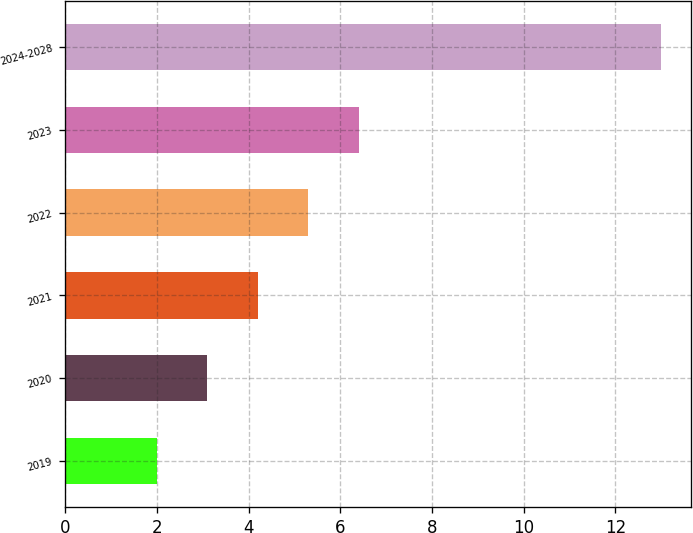Convert chart to OTSL. <chart><loc_0><loc_0><loc_500><loc_500><bar_chart><fcel>2019<fcel>2020<fcel>2021<fcel>2022<fcel>2023<fcel>2024-2028<nl><fcel>2<fcel>3.1<fcel>4.2<fcel>5.3<fcel>6.4<fcel>13<nl></chart> 